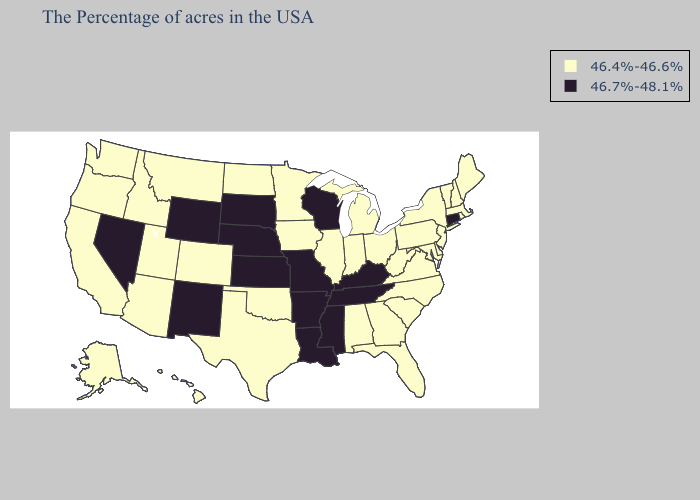Name the states that have a value in the range 46.7%-48.1%?
Quick response, please. Connecticut, Kentucky, Tennessee, Wisconsin, Mississippi, Louisiana, Missouri, Arkansas, Kansas, Nebraska, South Dakota, Wyoming, New Mexico, Nevada. Does Wyoming have the lowest value in the USA?
Keep it brief. No. Name the states that have a value in the range 46.4%-46.6%?
Short answer required. Maine, Massachusetts, Rhode Island, New Hampshire, Vermont, New York, New Jersey, Delaware, Maryland, Pennsylvania, Virginia, North Carolina, South Carolina, West Virginia, Ohio, Florida, Georgia, Michigan, Indiana, Alabama, Illinois, Minnesota, Iowa, Oklahoma, Texas, North Dakota, Colorado, Utah, Montana, Arizona, Idaho, California, Washington, Oregon, Alaska, Hawaii. What is the lowest value in the USA?
Write a very short answer. 46.4%-46.6%. Does Wisconsin have the lowest value in the USA?
Write a very short answer. No. Does the map have missing data?
Keep it brief. No. Does Michigan have the lowest value in the MidWest?
Keep it brief. Yes. What is the lowest value in states that border Ohio?
Give a very brief answer. 46.4%-46.6%. Among the states that border Kentucky , which have the lowest value?
Give a very brief answer. Virginia, West Virginia, Ohio, Indiana, Illinois. What is the highest value in the Northeast ?
Short answer required. 46.7%-48.1%. Name the states that have a value in the range 46.4%-46.6%?
Answer briefly. Maine, Massachusetts, Rhode Island, New Hampshire, Vermont, New York, New Jersey, Delaware, Maryland, Pennsylvania, Virginia, North Carolina, South Carolina, West Virginia, Ohio, Florida, Georgia, Michigan, Indiana, Alabama, Illinois, Minnesota, Iowa, Oklahoma, Texas, North Dakota, Colorado, Utah, Montana, Arizona, Idaho, California, Washington, Oregon, Alaska, Hawaii. Among the states that border Michigan , which have the lowest value?
Write a very short answer. Ohio, Indiana. What is the value of Vermont?
Give a very brief answer. 46.4%-46.6%. Is the legend a continuous bar?
Be succinct. No. Does Kentucky have the lowest value in the USA?
Be succinct. No. 